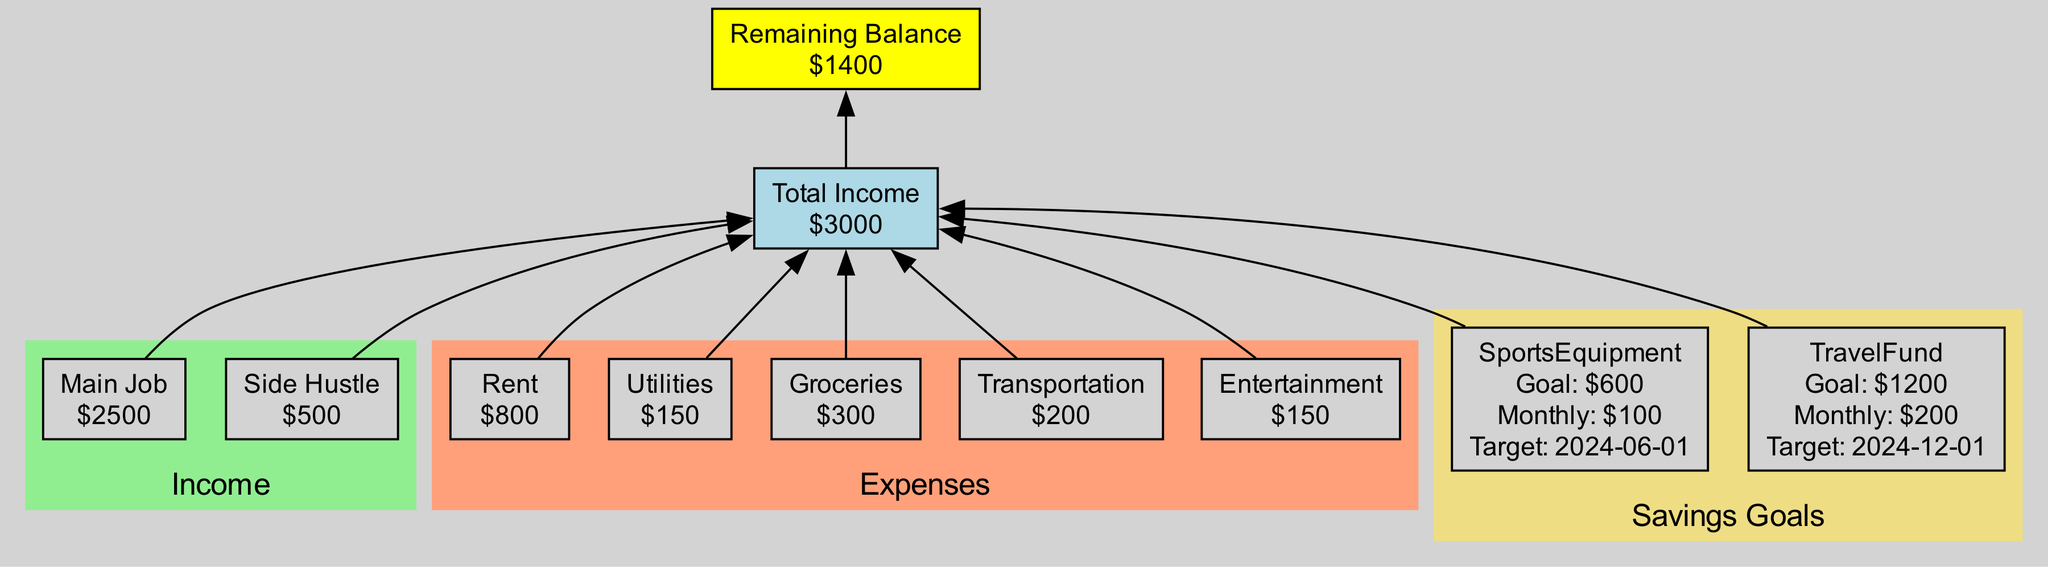What is the total income? By looking at the Total Income node in the diagram, it shows the amount of income combined from both the main job and the side hustle, which totals to 3000.
Answer: 3000 How much is allocated for groceries? The Expenses cluster indicates that the amount allocated for groceries is shown in the Groceries node, which states that it is 300.
Answer: 300 What is the goal amount for the Sports Equipment savings? In the Savings Goals cluster, the Sports Equipment node lists a Goal Amount of 600, which represents how much is being saved for that specific goal.
Answer: 600 How much is the monthly contribution to the Travel Fund? The diagram shows in the Travel Fund node that the Monthly Contribution is set at 200, which refers to how much is being set aside each month for this goal.
Answer: 200 What is the remaining balance after expenses? The Remaining Balance node indicates that after accounting for all expenses, the Net Savings is shown as 1400, which highlights what is left from the total income after expenses.
Answer: 1400 How many total expenses are listed in the diagram? The Expenses cluster contains five nodes: Rent, Utilities, Groceries, Transportation, and Entertainment, totaling to five distinct expense categories illustrated in the diagram.
Answer: 5 What is the target date for the Sports Equipment savings? The Sports Equipment node within the Savings Goals cluster highlights that the Target Date for achieving this savings goal is set for June 1, 2024.
Answer: 2024-06-01 Which income source contributes the least amount? By reviewing the Income cluster, the Side Hustle node shows that it contributes 500, which is less compared to the Main Job's 2500, making it the smallest source of income.
Answer: Side Hustle How much is spent on transportation? The Expenses cluster contains a Transportation node, which specifies that the expenditure for transportation is noted as 200, representing a specific portion of the overall budget.
Answer: 200 